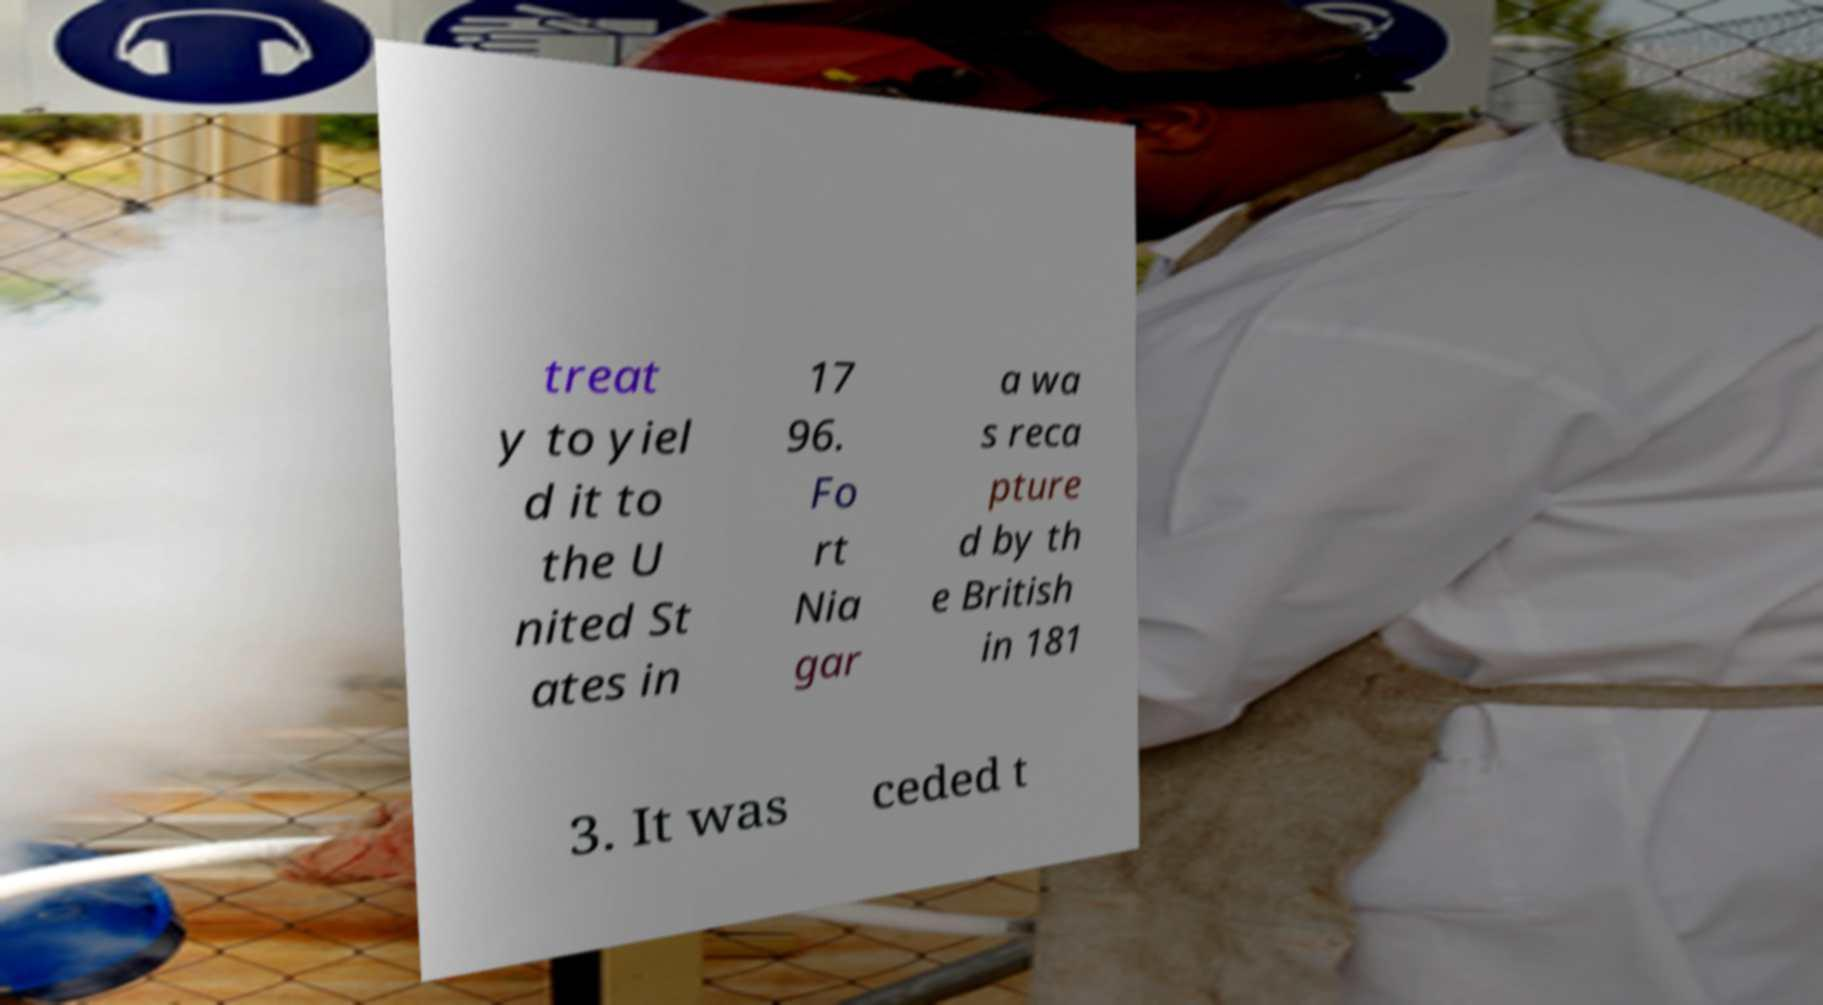There's text embedded in this image that I need extracted. Can you transcribe it verbatim? treat y to yiel d it to the U nited St ates in 17 96. Fo rt Nia gar a wa s reca pture d by th e British in 181 3. It was ceded t 